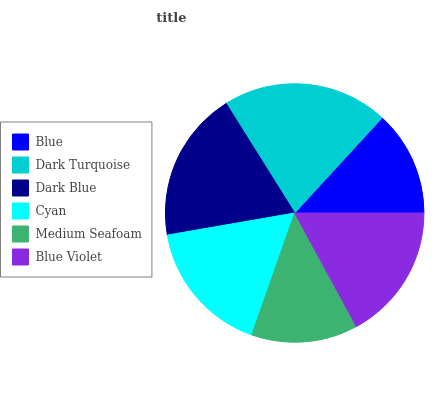Is Blue the minimum?
Answer yes or no. Yes. Is Dark Turquoise the maximum?
Answer yes or no. Yes. Is Dark Blue the minimum?
Answer yes or no. No. Is Dark Blue the maximum?
Answer yes or no. No. Is Dark Turquoise greater than Dark Blue?
Answer yes or no. Yes. Is Dark Blue less than Dark Turquoise?
Answer yes or no. Yes. Is Dark Blue greater than Dark Turquoise?
Answer yes or no. No. Is Dark Turquoise less than Dark Blue?
Answer yes or no. No. Is Blue Violet the high median?
Answer yes or no. Yes. Is Cyan the low median?
Answer yes or no. Yes. Is Cyan the high median?
Answer yes or no. No. Is Blue the low median?
Answer yes or no. No. 